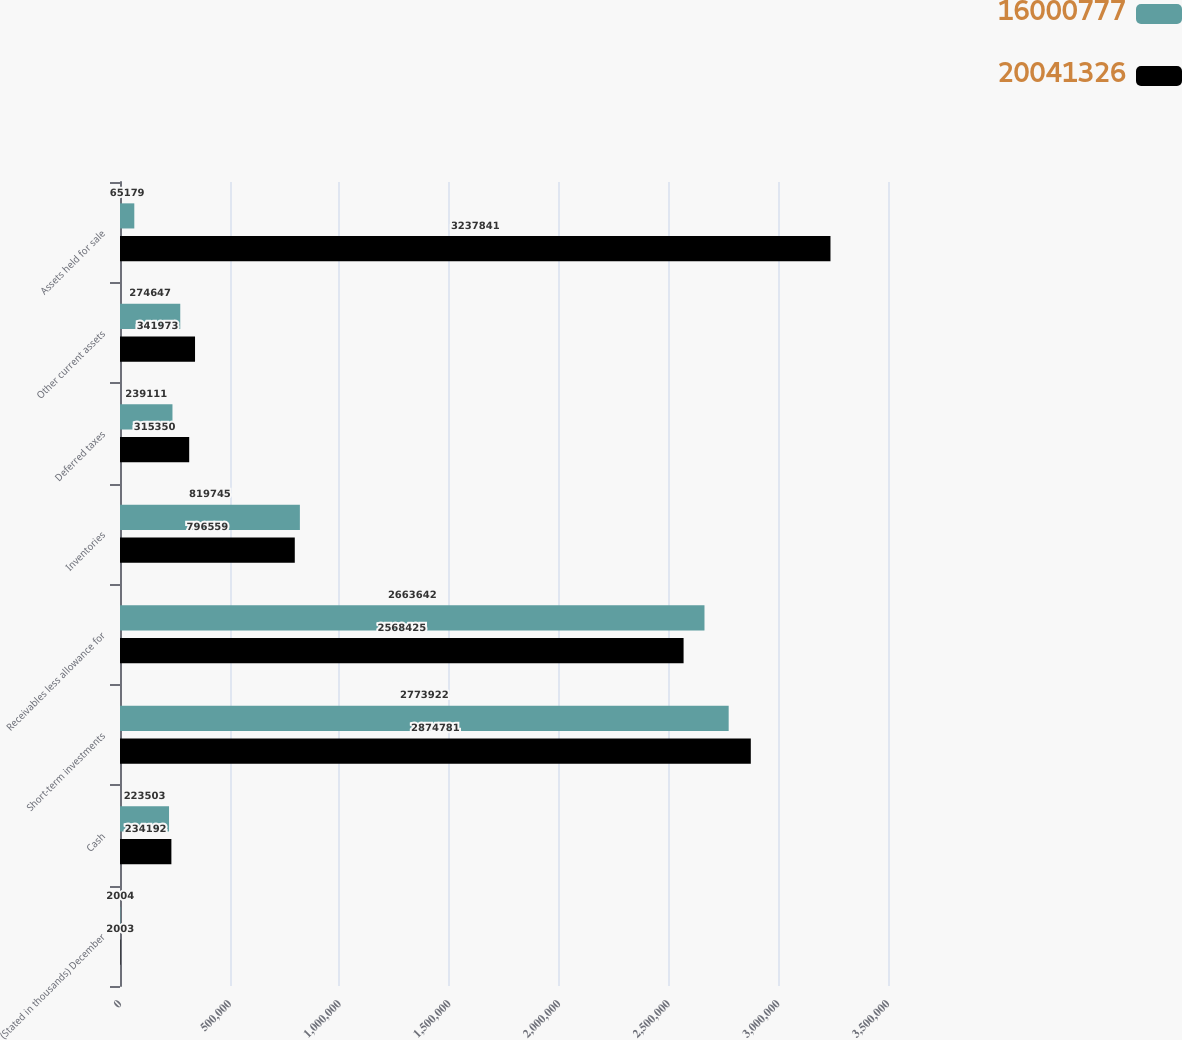Convert chart. <chart><loc_0><loc_0><loc_500><loc_500><stacked_bar_chart><ecel><fcel>(Stated in thousands) December<fcel>Cash<fcel>Short-term investments<fcel>Receivables less allowance for<fcel>Inventories<fcel>Deferred taxes<fcel>Other current assets<fcel>Assets held for sale<nl><fcel>1.60008e+07<fcel>2004<fcel>223503<fcel>2.77392e+06<fcel>2.66364e+06<fcel>819745<fcel>239111<fcel>274647<fcel>65179<nl><fcel>2.00413e+07<fcel>2003<fcel>234192<fcel>2.87478e+06<fcel>2.56842e+06<fcel>796559<fcel>315350<fcel>341973<fcel>3.23784e+06<nl></chart> 